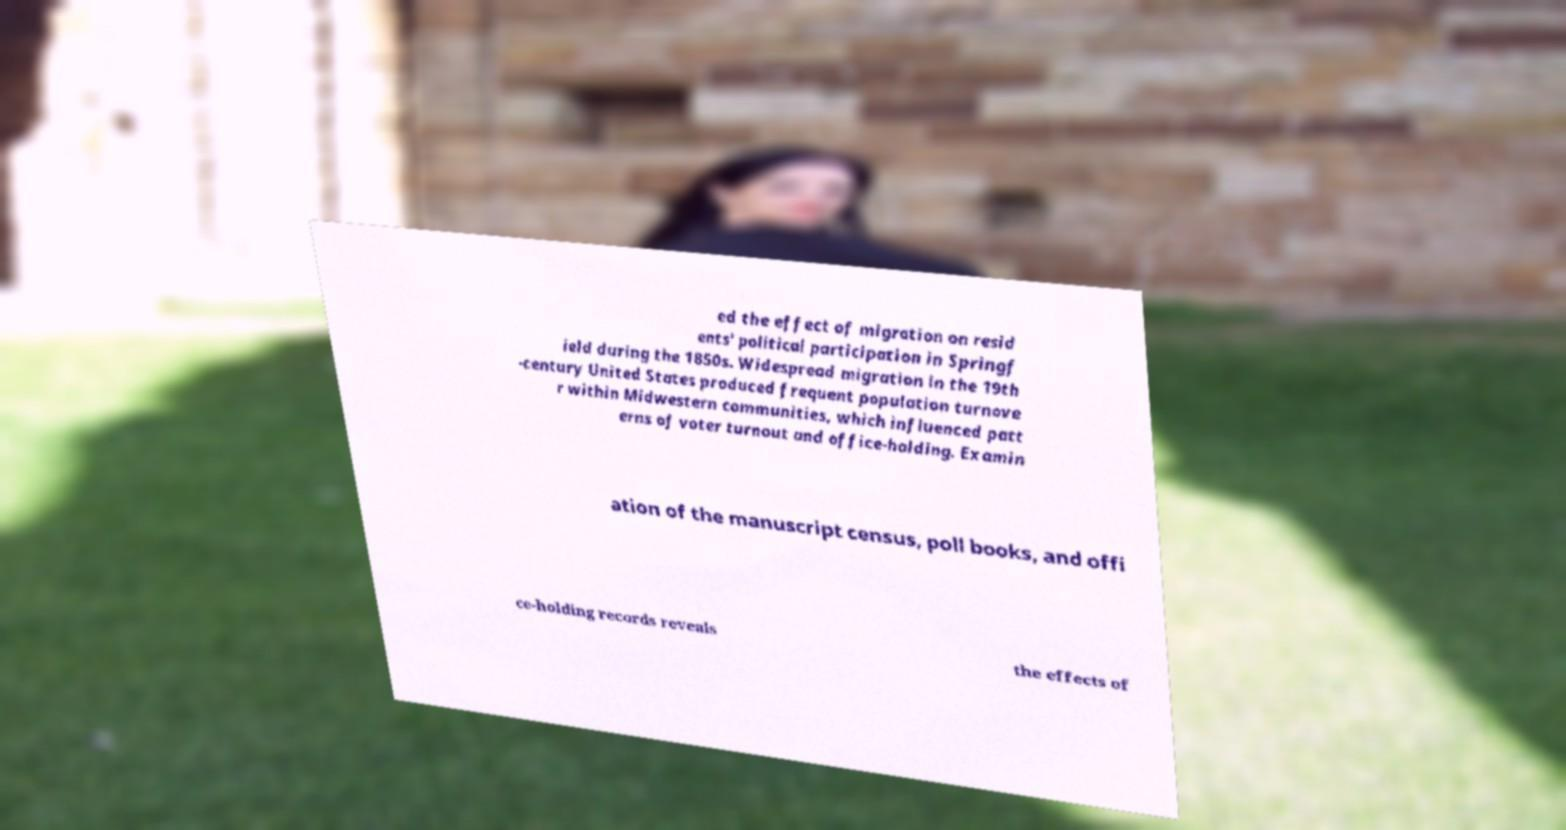I need the written content from this picture converted into text. Can you do that? ed the effect of migration on resid ents' political participation in Springf ield during the 1850s. Widespread migration in the 19th -century United States produced frequent population turnove r within Midwestern communities, which influenced patt erns of voter turnout and office-holding. Examin ation of the manuscript census, poll books, and offi ce-holding records reveals the effects of 